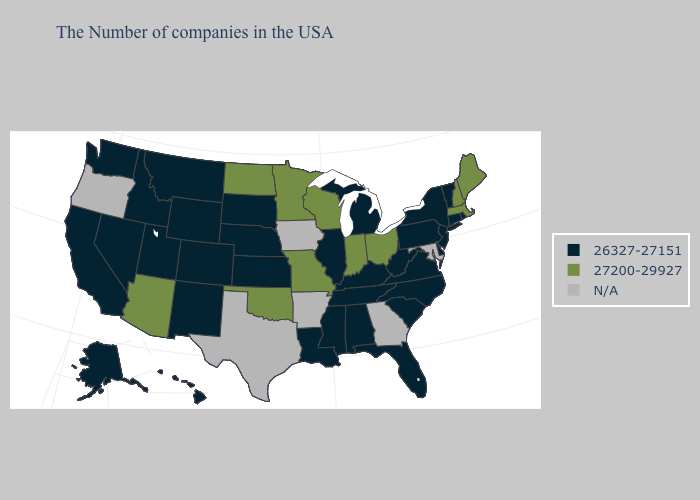How many symbols are there in the legend?
Write a very short answer. 3. What is the value of Minnesota?
Keep it brief. 27200-29927. What is the value of Montana?
Keep it brief. 26327-27151. Does Rhode Island have the highest value in the USA?
Quick response, please. No. Name the states that have a value in the range N/A?
Keep it brief. Maryland, Georgia, Arkansas, Iowa, Texas, Oregon. Which states have the highest value in the USA?
Be succinct. Maine, Massachusetts, New Hampshire, Ohio, Indiana, Wisconsin, Missouri, Minnesota, Oklahoma, North Dakota, Arizona. Name the states that have a value in the range 27200-29927?
Give a very brief answer. Maine, Massachusetts, New Hampshire, Ohio, Indiana, Wisconsin, Missouri, Minnesota, Oklahoma, North Dakota, Arizona. What is the highest value in the West ?
Short answer required. 27200-29927. Does the map have missing data?
Give a very brief answer. Yes. Which states have the lowest value in the USA?
Concise answer only. Rhode Island, Vermont, Connecticut, New York, New Jersey, Delaware, Pennsylvania, Virginia, North Carolina, South Carolina, West Virginia, Florida, Michigan, Kentucky, Alabama, Tennessee, Illinois, Mississippi, Louisiana, Kansas, Nebraska, South Dakota, Wyoming, Colorado, New Mexico, Utah, Montana, Idaho, Nevada, California, Washington, Alaska, Hawaii. What is the value of Vermont?
Write a very short answer. 26327-27151. Name the states that have a value in the range 26327-27151?
Keep it brief. Rhode Island, Vermont, Connecticut, New York, New Jersey, Delaware, Pennsylvania, Virginia, North Carolina, South Carolina, West Virginia, Florida, Michigan, Kentucky, Alabama, Tennessee, Illinois, Mississippi, Louisiana, Kansas, Nebraska, South Dakota, Wyoming, Colorado, New Mexico, Utah, Montana, Idaho, Nevada, California, Washington, Alaska, Hawaii. What is the value of Iowa?
Keep it brief. N/A. Which states have the lowest value in the Northeast?
Write a very short answer. Rhode Island, Vermont, Connecticut, New York, New Jersey, Pennsylvania. How many symbols are there in the legend?
Give a very brief answer. 3. 